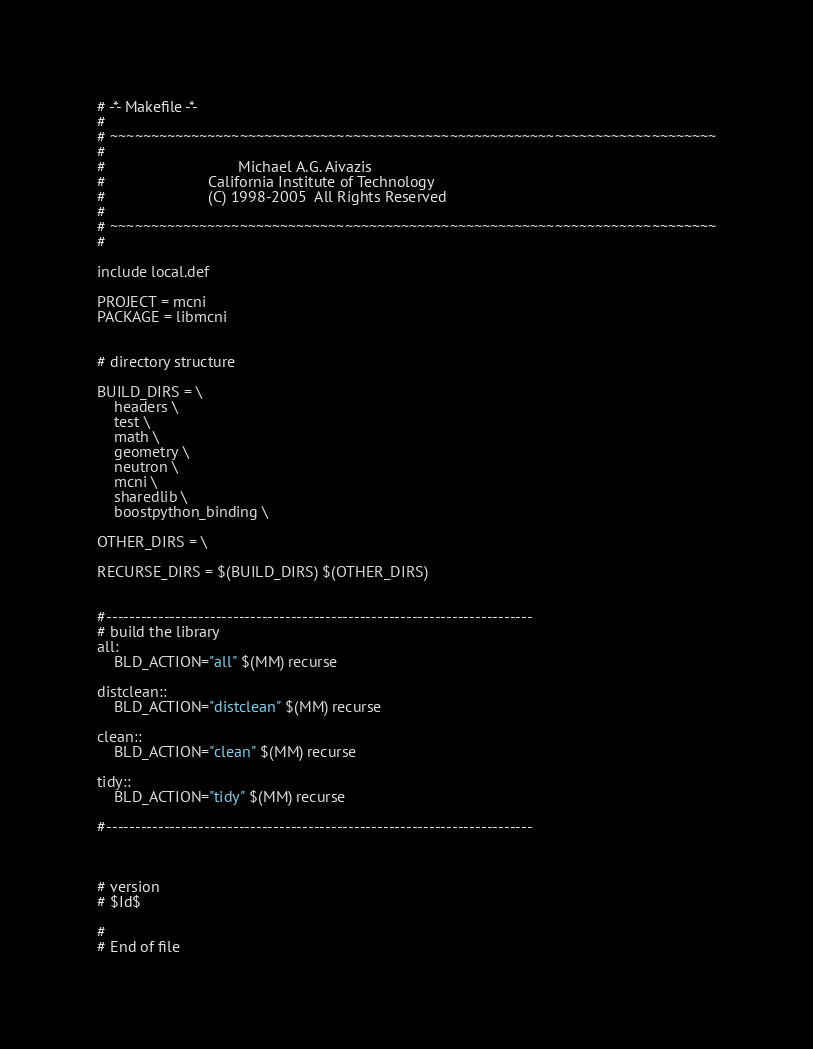<code> <loc_0><loc_0><loc_500><loc_500><_ObjectiveC_># -*- Makefile -*-
#
# ~~~~~~~~~~~~~~~~~~~~~~~~~~~~~~~~~~~~~~~~~~~~~~~~~~~~~~~~~~~~~~~~~~~~~~~~~~~
#
#                               Michael A.G. Aivazis
#                        California Institute of Technology
#                        (C) 1998-2005  All Rights Reserved
#
# ~~~~~~~~~~~~~~~~~~~~~~~~~~~~~~~~~~~~~~~~~~~~~~~~~~~~~~~~~~~~~~~~~~~~~~~~~~~
#

include local.def

PROJECT = mcni
PACKAGE = libmcni


# directory structure

BUILD_DIRS = \
	headers \
	test \
	math \
	geometry \
	neutron \
	mcni \
	sharedlib \
	boostpython_binding \

OTHER_DIRS = \

RECURSE_DIRS = $(BUILD_DIRS) $(OTHER_DIRS)


#--------------------------------------------------------------------------
# build the library
all: 
	BLD_ACTION="all" $(MM) recurse

distclean::
	BLD_ACTION="distclean" $(MM) recurse

clean::
	BLD_ACTION="clean" $(MM) recurse

tidy::
	BLD_ACTION="tidy" $(MM) recurse

#--------------------------------------------------------------------------



# version
# $Id$

#
# End of file
</code> 